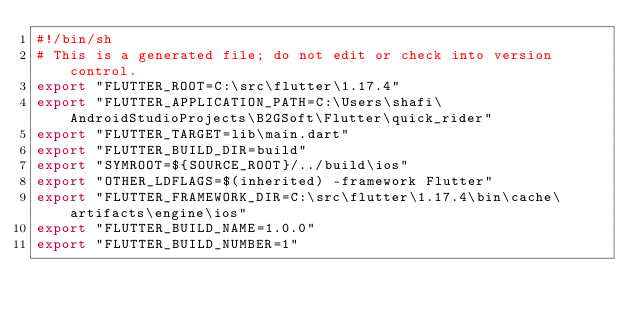<code> <loc_0><loc_0><loc_500><loc_500><_Bash_>#!/bin/sh
# This is a generated file; do not edit or check into version control.
export "FLUTTER_ROOT=C:\src\flutter\1.17.4"
export "FLUTTER_APPLICATION_PATH=C:\Users\shafi\AndroidStudioProjects\B2GSoft\Flutter\quick_rider"
export "FLUTTER_TARGET=lib\main.dart"
export "FLUTTER_BUILD_DIR=build"
export "SYMROOT=${SOURCE_ROOT}/../build\ios"
export "OTHER_LDFLAGS=$(inherited) -framework Flutter"
export "FLUTTER_FRAMEWORK_DIR=C:\src\flutter\1.17.4\bin\cache\artifacts\engine\ios"
export "FLUTTER_BUILD_NAME=1.0.0"
export "FLUTTER_BUILD_NUMBER=1"
</code> 